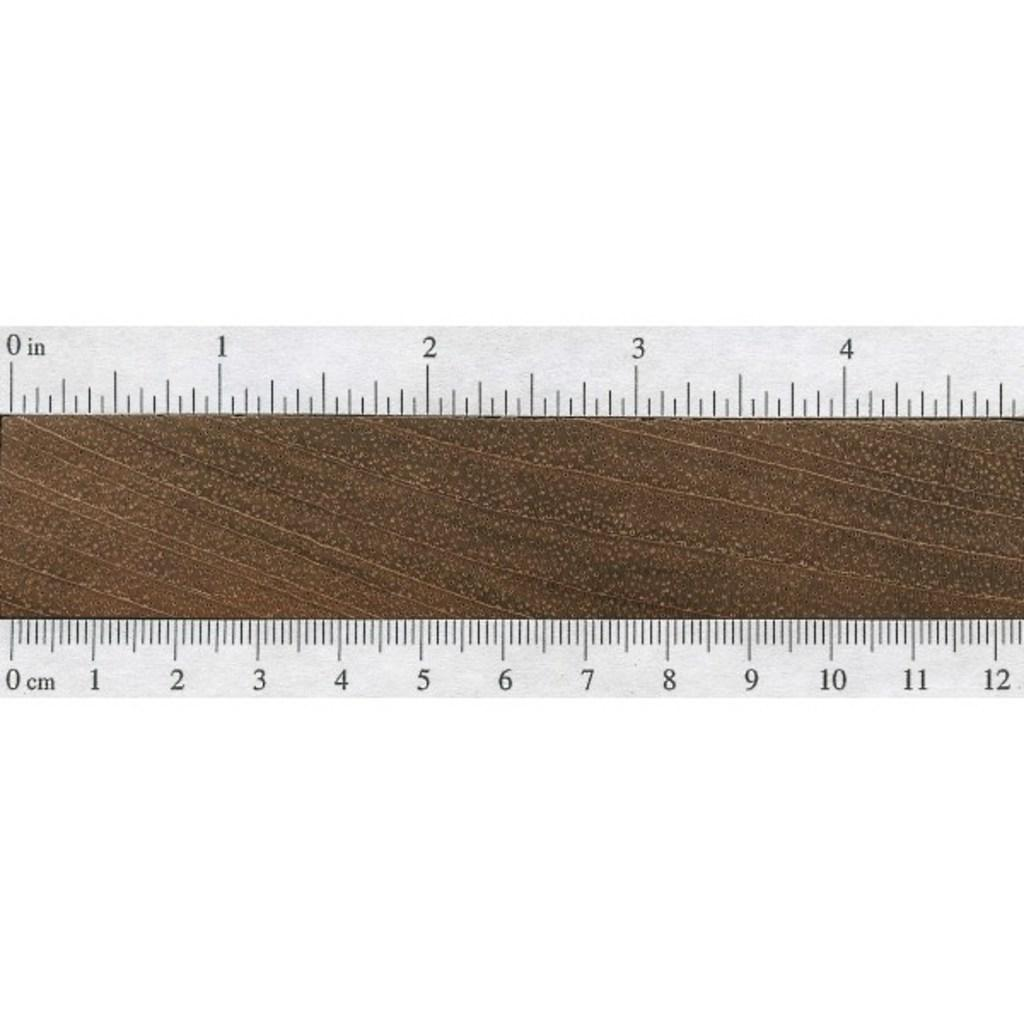<image>
Share a concise interpretation of the image provided. a ruler with clear sides and a brown middle secton that measures in inches and centimeters. 